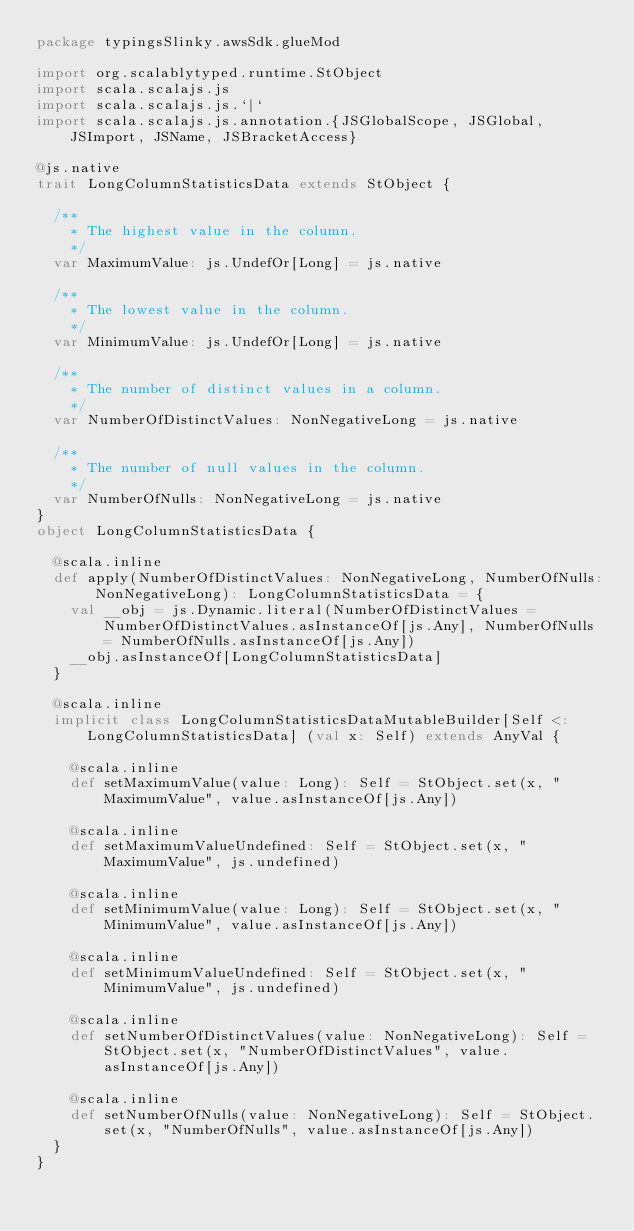Convert code to text. <code><loc_0><loc_0><loc_500><loc_500><_Scala_>package typingsSlinky.awsSdk.glueMod

import org.scalablytyped.runtime.StObject
import scala.scalajs.js
import scala.scalajs.js.`|`
import scala.scalajs.js.annotation.{JSGlobalScope, JSGlobal, JSImport, JSName, JSBracketAccess}

@js.native
trait LongColumnStatisticsData extends StObject {
  
  /**
    * The highest value in the column.
    */
  var MaximumValue: js.UndefOr[Long] = js.native
  
  /**
    * The lowest value in the column.
    */
  var MinimumValue: js.UndefOr[Long] = js.native
  
  /**
    * The number of distinct values in a column.
    */
  var NumberOfDistinctValues: NonNegativeLong = js.native
  
  /**
    * The number of null values in the column.
    */
  var NumberOfNulls: NonNegativeLong = js.native
}
object LongColumnStatisticsData {
  
  @scala.inline
  def apply(NumberOfDistinctValues: NonNegativeLong, NumberOfNulls: NonNegativeLong): LongColumnStatisticsData = {
    val __obj = js.Dynamic.literal(NumberOfDistinctValues = NumberOfDistinctValues.asInstanceOf[js.Any], NumberOfNulls = NumberOfNulls.asInstanceOf[js.Any])
    __obj.asInstanceOf[LongColumnStatisticsData]
  }
  
  @scala.inline
  implicit class LongColumnStatisticsDataMutableBuilder[Self <: LongColumnStatisticsData] (val x: Self) extends AnyVal {
    
    @scala.inline
    def setMaximumValue(value: Long): Self = StObject.set(x, "MaximumValue", value.asInstanceOf[js.Any])
    
    @scala.inline
    def setMaximumValueUndefined: Self = StObject.set(x, "MaximumValue", js.undefined)
    
    @scala.inline
    def setMinimumValue(value: Long): Self = StObject.set(x, "MinimumValue", value.asInstanceOf[js.Any])
    
    @scala.inline
    def setMinimumValueUndefined: Self = StObject.set(x, "MinimumValue", js.undefined)
    
    @scala.inline
    def setNumberOfDistinctValues(value: NonNegativeLong): Self = StObject.set(x, "NumberOfDistinctValues", value.asInstanceOf[js.Any])
    
    @scala.inline
    def setNumberOfNulls(value: NonNegativeLong): Self = StObject.set(x, "NumberOfNulls", value.asInstanceOf[js.Any])
  }
}
</code> 